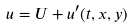Convert formula to latex. <formula><loc_0><loc_0><loc_500><loc_500>u = U + u ^ { \prime } ( t , x , y )</formula> 